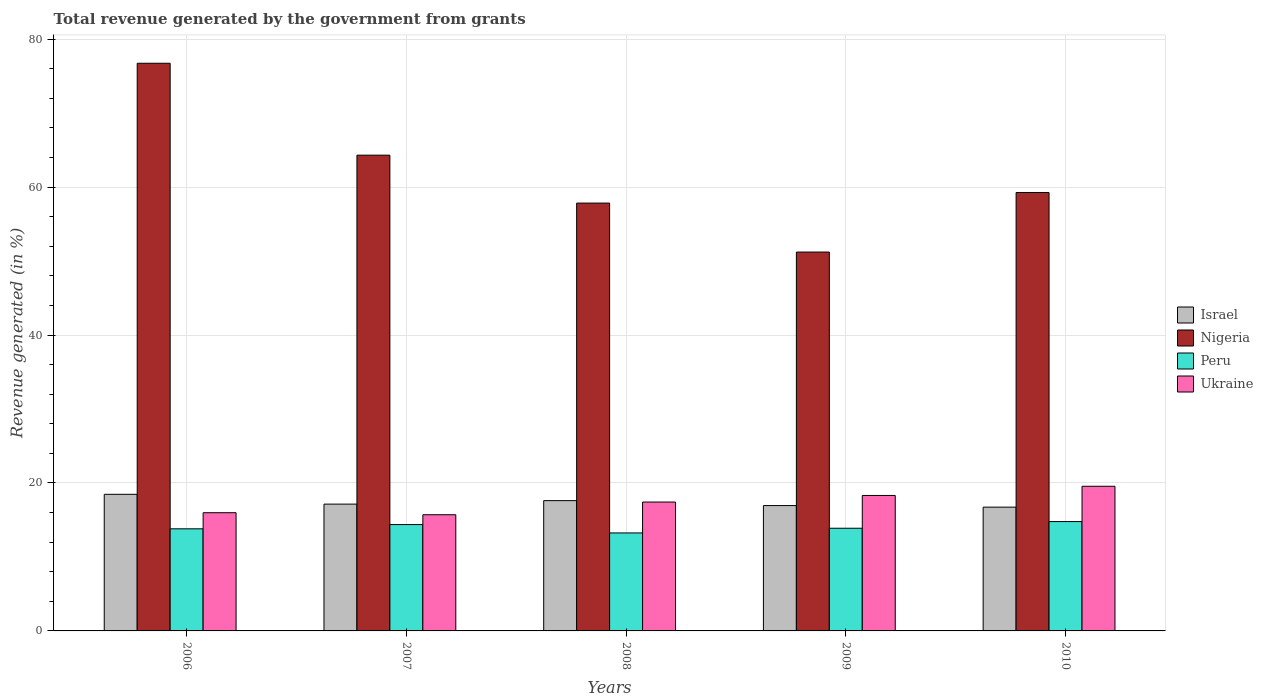How many different coloured bars are there?
Offer a very short reply. 4. What is the label of the 1st group of bars from the left?
Provide a succinct answer. 2006. In how many cases, is the number of bars for a given year not equal to the number of legend labels?
Your answer should be very brief. 0. What is the total revenue generated in Nigeria in 2009?
Offer a very short reply. 51.22. Across all years, what is the maximum total revenue generated in Ukraine?
Give a very brief answer. 19.55. Across all years, what is the minimum total revenue generated in Israel?
Provide a short and direct response. 16.73. What is the total total revenue generated in Ukraine in the graph?
Give a very brief answer. 86.97. What is the difference between the total revenue generated in Nigeria in 2006 and that in 2008?
Ensure brevity in your answer.  18.9. What is the difference between the total revenue generated in Ukraine in 2007 and the total revenue generated in Nigeria in 2008?
Make the answer very short. -42.13. What is the average total revenue generated in Peru per year?
Provide a succinct answer. 14.02. In the year 2008, what is the difference between the total revenue generated in Ukraine and total revenue generated in Peru?
Offer a very short reply. 4.18. What is the ratio of the total revenue generated in Ukraine in 2008 to that in 2009?
Offer a very short reply. 0.95. Is the total revenue generated in Peru in 2006 less than that in 2009?
Ensure brevity in your answer.  Yes. Is the difference between the total revenue generated in Ukraine in 2006 and 2007 greater than the difference between the total revenue generated in Peru in 2006 and 2007?
Your answer should be very brief. Yes. What is the difference between the highest and the second highest total revenue generated in Israel?
Make the answer very short. 0.85. What is the difference between the highest and the lowest total revenue generated in Peru?
Your answer should be compact. 1.54. In how many years, is the total revenue generated in Nigeria greater than the average total revenue generated in Nigeria taken over all years?
Provide a succinct answer. 2. Is the sum of the total revenue generated in Israel in 2006 and 2007 greater than the maximum total revenue generated in Ukraine across all years?
Provide a succinct answer. Yes. Are all the bars in the graph horizontal?
Provide a succinct answer. No. How many years are there in the graph?
Provide a short and direct response. 5. Are the values on the major ticks of Y-axis written in scientific E-notation?
Your answer should be compact. No. Does the graph contain any zero values?
Your answer should be compact. No. Does the graph contain grids?
Give a very brief answer. Yes. Where does the legend appear in the graph?
Your answer should be compact. Center right. How are the legend labels stacked?
Provide a succinct answer. Vertical. What is the title of the graph?
Your answer should be very brief. Total revenue generated by the government from grants. Does "Gambia, The" appear as one of the legend labels in the graph?
Your answer should be compact. No. What is the label or title of the Y-axis?
Provide a short and direct response. Revenue generated (in %). What is the Revenue generated (in %) in Israel in 2006?
Offer a terse response. 18.47. What is the Revenue generated (in %) of Nigeria in 2006?
Your answer should be compact. 76.74. What is the Revenue generated (in %) of Peru in 2006?
Your response must be concise. 13.8. What is the Revenue generated (in %) of Ukraine in 2006?
Provide a succinct answer. 15.98. What is the Revenue generated (in %) of Israel in 2007?
Keep it short and to the point. 17.14. What is the Revenue generated (in %) in Nigeria in 2007?
Provide a succinct answer. 64.31. What is the Revenue generated (in %) in Peru in 2007?
Provide a short and direct response. 14.38. What is the Revenue generated (in %) of Ukraine in 2007?
Offer a very short reply. 15.7. What is the Revenue generated (in %) of Israel in 2008?
Give a very brief answer. 17.61. What is the Revenue generated (in %) of Nigeria in 2008?
Ensure brevity in your answer.  57.84. What is the Revenue generated (in %) of Peru in 2008?
Ensure brevity in your answer.  13.24. What is the Revenue generated (in %) of Ukraine in 2008?
Provide a succinct answer. 17.42. What is the Revenue generated (in %) of Israel in 2009?
Give a very brief answer. 16.95. What is the Revenue generated (in %) of Nigeria in 2009?
Provide a short and direct response. 51.22. What is the Revenue generated (in %) in Peru in 2009?
Your answer should be very brief. 13.88. What is the Revenue generated (in %) in Ukraine in 2009?
Offer a terse response. 18.31. What is the Revenue generated (in %) of Israel in 2010?
Your response must be concise. 16.73. What is the Revenue generated (in %) in Nigeria in 2010?
Offer a very short reply. 59.27. What is the Revenue generated (in %) of Peru in 2010?
Make the answer very short. 14.78. What is the Revenue generated (in %) of Ukraine in 2010?
Your answer should be very brief. 19.55. Across all years, what is the maximum Revenue generated (in %) in Israel?
Your answer should be very brief. 18.47. Across all years, what is the maximum Revenue generated (in %) of Nigeria?
Your answer should be compact. 76.74. Across all years, what is the maximum Revenue generated (in %) in Peru?
Give a very brief answer. 14.78. Across all years, what is the maximum Revenue generated (in %) in Ukraine?
Offer a very short reply. 19.55. Across all years, what is the minimum Revenue generated (in %) in Israel?
Your answer should be compact. 16.73. Across all years, what is the minimum Revenue generated (in %) in Nigeria?
Your answer should be very brief. 51.22. Across all years, what is the minimum Revenue generated (in %) in Peru?
Make the answer very short. 13.24. Across all years, what is the minimum Revenue generated (in %) of Ukraine?
Your answer should be very brief. 15.7. What is the total Revenue generated (in %) of Israel in the graph?
Your response must be concise. 86.9. What is the total Revenue generated (in %) of Nigeria in the graph?
Your response must be concise. 309.37. What is the total Revenue generated (in %) in Peru in the graph?
Make the answer very short. 70.09. What is the total Revenue generated (in %) of Ukraine in the graph?
Give a very brief answer. 86.97. What is the difference between the Revenue generated (in %) of Israel in 2006 and that in 2007?
Keep it short and to the point. 1.32. What is the difference between the Revenue generated (in %) of Nigeria in 2006 and that in 2007?
Offer a terse response. 12.42. What is the difference between the Revenue generated (in %) of Peru in 2006 and that in 2007?
Offer a very short reply. -0.57. What is the difference between the Revenue generated (in %) of Ukraine in 2006 and that in 2007?
Keep it short and to the point. 0.28. What is the difference between the Revenue generated (in %) of Israel in 2006 and that in 2008?
Offer a very short reply. 0.85. What is the difference between the Revenue generated (in %) of Nigeria in 2006 and that in 2008?
Your answer should be compact. 18.9. What is the difference between the Revenue generated (in %) in Peru in 2006 and that in 2008?
Your answer should be very brief. 0.56. What is the difference between the Revenue generated (in %) in Ukraine in 2006 and that in 2008?
Offer a terse response. -1.44. What is the difference between the Revenue generated (in %) in Israel in 2006 and that in 2009?
Provide a succinct answer. 1.52. What is the difference between the Revenue generated (in %) in Nigeria in 2006 and that in 2009?
Your response must be concise. 25.52. What is the difference between the Revenue generated (in %) of Peru in 2006 and that in 2009?
Your answer should be very brief. -0.08. What is the difference between the Revenue generated (in %) in Ukraine in 2006 and that in 2009?
Keep it short and to the point. -2.33. What is the difference between the Revenue generated (in %) in Israel in 2006 and that in 2010?
Your answer should be very brief. 1.73. What is the difference between the Revenue generated (in %) in Nigeria in 2006 and that in 2010?
Offer a very short reply. 17.47. What is the difference between the Revenue generated (in %) of Peru in 2006 and that in 2010?
Your answer should be compact. -0.98. What is the difference between the Revenue generated (in %) in Ukraine in 2006 and that in 2010?
Make the answer very short. -3.57. What is the difference between the Revenue generated (in %) of Israel in 2007 and that in 2008?
Make the answer very short. -0.47. What is the difference between the Revenue generated (in %) of Nigeria in 2007 and that in 2008?
Offer a terse response. 6.48. What is the difference between the Revenue generated (in %) in Peru in 2007 and that in 2008?
Ensure brevity in your answer.  1.13. What is the difference between the Revenue generated (in %) in Ukraine in 2007 and that in 2008?
Provide a short and direct response. -1.72. What is the difference between the Revenue generated (in %) of Israel in 2007 and that in 2009?
Your answer should be very brief. 0.2. What is the difference between the Revenue generated (in %) in Nigeria in 2007 and that in 2009?
Provide a short and direct response. 13.1. What is the difference between the Revenue generated (in %) in Peru in 2007 and that in 2009?
Ensure brevity in your answer.  0.5. What is the difference between the Revenue generated (in %) of Ukraine in 2007 and that in 2009?
Keep it short and to the point. -2.61. What is the difference between the Revenue generated (in %) of Israel in 2007 and that in 2010?
Offer a very short reply. 0.41. What is the difference between the Revenue generated (in %) in Nigeria in 2007 and that in 2010?
Keep it short and to the point. 5.05. What is the difference between the Revenue generated (in %) of Peru in 2007 and that in 2010?
Provide a succinct answer. -0.41. What is the difference between the Revenue generated (in %) of Ukraine in 2007 and that in 2010?
Provide a succinct answer. -3.85. What is the difference between the Revenue generated (in %) of Israel in 2008 and that in 2009?
Provide a short and direct response. 0.67. What is the difference between the Revenue generated (in %) of Nigeria in 2008 and that in 2009?
Offer a terse response. 6.62. What is the difference between the Revenue generated (in %) of Peru in 2008 and that in 2009?
Your response must be concise. -0.64. What is the difference between the Revenue generated (in %) of Ukraine in 2008 and that in 2009?
Your answer should be compact. -0.89. What is the difference between the Revenue generated (in %) in Israel in 2008 and that in 2010?
Your answer should be very brief. 0.88. What is the difference between the Revenue generated (in %) in Nigeria in 2008 and that in 2010?
Keep it short and to the point. -1.43. What is the difference between the Revenue generated (in %) in Peru in 2008 and that in 2010?
Your answer should be compact. -1.54. What is the difference between the Revenue generated (in %) of Ukraine in 2008 and that in 2010?
Give a very brief answer. -2.13. What is the difference between the Revenue generated (in %) of Israel in 2009 and that in 2010?
Your answer should be compact. 0.21. What is the difference between the Revenue generated (in %) in Nigeria in 2009 and that in 2010?
Ensure brevity in your answer.  -8.05. What is the difference between the Revenue generated (in %) in Peru in 2009 and that in 2010?
Give a very brief answer. -0.9. What is the difference between the Revenue generated (in %) of Ukraine in 2009 and that in 2010?
Ensure brevity in your answer.  -1.24. What is the difference between the Revenue generated (in %) of Israel in 2006 and the Revenue generated (in %) of Nigeria in 2007?
Your answer should be compact. -45.85. What is the difference between the Revenue generated (in %) of Israel in 2006 and the Revenue generated (in %) of Peru in 2007?
Provide a succinct answer. 4.09. What is the difference between the Revenue generated (in %) of Israel in 2006 and the Revenue generated (in %) of Ukraine in 2007?
Give a very brief answer. 2.76. What is the difference between the Revenue generated (in %) of Nigeria in 2006 and the Revenue generated (in %) of Peru in 2007?
Offer a terse response. 62.36. What is the difference between the Revenue generated (in %) of Nigeria in 2006 and the Revenue generated (in %) of Ukraine in 2007?
Your response must be concise. 61.03. What is the difference between the Revenue generated (in %) in Peru in 2006 and the Revenue generated (in %) in Ukraine in 2007?
Make the answer very short. -1.9. What is the difference between the Revenue generated (in %) of Israel in 2006 and the Revenue generated (in %) of Nigeria in 2008?
Ensure brevity in your answer.  -39.37. What is the difference between the Revenue generated (in %) of Israel in 2006 and the Revenue generated (in %) of Peru in 2008?
Give a very brief answer. 5.22. What is the difference between the Revenue generated (in %) in Israel in 2006 and the Revenue generated (in %) in Ukraine in 2008?
Make the answer very short. 1.04. What is the difference between the Revenue generated (in %) of Nigeria in 2006 and the Revenue generated (in %) of Peru in 2008?
Your answer should be compact. 63.49. What is the difference between the Revenue generated (in %) of Nigeria in 2006 and the Revenue generated (in %) of Ukraine in 2008?
Your response must be concise. 59.32. What is the difference between the Revenue generated (in %) of Peru in 2006 and the Revenue generated (in %) of Ukraine in 2008?
Ensure brevity in your answer.  -3.62. What is the difference between the Revenue generated (in %) of Israel in 2006 and the Revenue generated (in %) of Nigeria in 2009?
Offer a very short reply. -32.75. What is the difference between the Revenue generated (in %) in Israel in 2006 and the Revenue generated (in %) in Peru in 2009?
Offer a terse response. 4.59. What is the difference between the Revenue generated (in %) of Israel in 2006 and the Revenue generated (in %) of Ukraine in 2009?
Keep it short and to the point. 0.15. What is the difference between the Revenue generated (in %) in Nigeria in 2006 and the Revenue generated (in %) in Peru in 2009?
Provide a succinct answer. 62.86. What is the difference between the Revenue generated (in %) in Nigeria in 2006 and the Revenue generated (in %) in Ukraine in 2009?
Your response must be concise. 58.43. What is the difference between the Revenue generated (in %) of Peru in 2006 and the Revenue generated (in %) of Ukraine in 2009?
Ensure brevity in your answer.  -4.51. What is the difference between the Revenue generated (in %) in Israel in 2006 and the Revenue generated (in %) in Nigeria in 2010?
Offer a terse response. -40.8. What is the difference between the Revenue generated (in %) in Israel in 2006 and the Revenue generated (in %) in Peru in 2010?
Give a very brief answer. 3.68. What is the difference between the Revenue generated (in %) of Israel in 2006 and the Revenue generated (in %) of Ukraine in 2010?
Ensure brevity in your answer.  -1.09. What is the difference between the Revenue generated (in %) of Nigeria in 2006 and the Revenue generated (in %) of Peru in 2010?
Make the answer very short. 61.96. What is the difference between the Revenue generated (in %) in Nigeria in 2006 and the Revenue generated (in %) in Ukraine in 2010?
Your response must be concise. 57.18. What is the difference between the Revenue generated (in %) of Peru in 2006 and the Revenue generated (in %) of Ukraine in 2010?
Your answer should be very brief. -5.75. What is the difference between the Revenue generated (in %) of Israel in 2007 and the Revenue generated (in %) of Nigeria in 2008?
Give a very brief answer. -40.69. What is the difference between the Revenue generated (in %) in Israel in 2007 and the Revenue generated (in %) in Peru in 2008?
Provide a short and direct response. 3.9. What is the difference between the Revenue generated (in %) in Israel in 2007 and the Revenue generated (in %) in Ukraine in 2008?
Provide a short and direct response. -0.28. What is the difference between the Revenue generated (in %) in Nigeria in 2007 and the Revenue generated (in %) in Peru in 2008?
Provide a succinct answer. 51.07. What is the difference between the Revenue generated (in %) in Nigeria in 2007 and the Revenue generated (in %) in Ukraine in 2008?
Your answer should be very brief. 46.89. What is the difference between the Revenue generated (in %) in Peru in 2007 and the Revenue generated (in %) in Ukraine in 2008?
Offer a terse response. -3.05. What is the difference between the Revenue generated (in %) in Israel in 2007 and the Revenue generated (in %) in Nigeria in 2009?
Offer a very short reply. -34.07. What is the difference between the Revenue generated (in %) of Israel in 2007 and the Revenue generated (in %) of Peru in 2009?
Ensure brevity in your answer.  3.26. What is the difference between the Revenue generated (in %) of Israel in 2007 and the Revenue generated (in %) of Ukraine in 2009?
Keep it short and to the point. -1.17. What is the difference between the Revenue generated (in %) in Nigeria in 2007 and the Revenue generated (in %) in Peru in 2009?
Offer a terse response. 50.43. What is the difference between the Revenue generated (in %) in Nigeria in 2007 and the Revenue generated (in %) in Ukraine in 2009?
Offer a very short reply. 46. What is the difference between the Revenue generated (in %) of Peru in 2007 and the Revenue generated (in %) of Ukraine in 2009?
Your answer should be very brief. -3.93. What is the difference between the Revenue generated (in %) of Israel in 2007 and the Revenue generated (in %) of Nigeria in 2010?
Offer a very short reply. -42.13. What is the difference between the Revenue generated (in %) in Israel in 2007 and the Revenue generated (in %) in Peru in 2010?
Provide a succinct answer. 2.36. What is the difference between the Revenue generated (in %) in Israel in 2007 and the Revenue generated (in %) in Ukraine in 2010?
Offer a very short reply. -2.41. What is the difference between the Revenue generated (in %) in Nigeria in 2007 and the Revenue generated (in %) in Peru in 2010?
Keep it short and to the point. 49.53. What is the difference between the Revenue generated (in %) of Nigeria in 2007 and the Revenue generated (in %) of Ukraine in 2010?
Give a very brief answer. 44.76. What is the difference between the Revenue generated (in %) of Peru in 2007 and the Revenue generated (in %) of Ukraine in 2010?
Provide a short and direct response. -5.18. What is the difference between the Revenue generated (in %) in Israel in 2008 and the Revenue generated (in %) in Nigeria in 2009?
Offer a very short reply. -33.6. What is the difference between the Revenue generated (in %) of Israel in 2008 and the Revenue generated (in %) of Peru in 2009?
Keep it short and to the point. 3.73. What is the difference between the Revenue generated (in %) of Israel in 2008 and the Revenue generated (in %) of Ukraine in 2009?
Offer a terse response. -0.7. What is the difference between the Revenue generated (in %) in Nigeria in 2008 and the Revenue generated (in %) in Peru in 2009?
Your answer should be very brief. 43.96. What is the difference between the Revenue generated (in %) in Nigeria in 2008 and the Revenue generated (in %) in Ukraine in 2009?
Offer a very short reply. 39.52. What is the difference between the Revenue generated (in %) in Peru in 2008 and the Revenue generated (in %) in Ukraine in 2009?
Your answer should be very brief. -5.07. What is the difference between the Revenue generated (in %) of Israel in 2008 and the Revenue generated (in %) of Nigeria in 2010?
Your answer should be very brief. -41.65. What is the difference between the Revenue generated (in %) in Israel in 2008 and the Revenue generated (in %) in Peru in 2010?
Your answer should be compact. 2.83. What is the difference between the Revenue generated (in %) of Israel in 2008 and the Revenue generated (in %) of Ukraine in 2010?
Offer a very short reply. -1.94. What is the difference between the Revenue generated (in %) in Nigeria in 2008 and the Revenue generated (in %) in Peru in 2010?
Give a very brief answer. 43.05. What is the difference between the Revenue generated (in %) of Nigeria in 2008 and the Revenue generated (in %) of Ukraine in 2010?
Provide a short and direct response. 38.28. What is the difference between the Revenue generated (in %) in Peru in 2008 and the Revenue generated (in %) in Ukraine in 2010?
Make the answer very short. -6.31. What is the difference between the Revenue generated (in %) in Israel in 2009 and the Revenue generated (in %) in Nigeria in 2010?
Keep it short and to the point. -42.32. What is the difference between the Revenue generated (in %) of Israel in 2009 and the Revenue generated (in %) of Peru in 2010?
Give a very brief answer. 2.16. What is the difference between the Revenue generated (in %) of Israel in 2009 and the Revenue generated (in %) of Ukraine in 2010?
Offer a very short reply. -2.61. What is the difference between the Revenue generated (in %) in Nigeria in 2009 and the Revenue generated (in %) in Peru in 2010?
Keep it short and to the point. 36.43. What is the difference between the Revenue generated (in %) of Nigeria in 2009 and the Revenue generated (in %) of Ukraine in 2010?
Your response must be concise. 31.66. What is the difference between the Revenue generated (in %) in Peru in 2009 and the Revenue generated (in %) in Ukraine in 2010?
Ensure brevity in your answer.  -5.67. What is the average Revenue generated (in %) in Israel per year?
Provide a short and direct response. 17.38. What is the average Revenue generated (in %) in Nigeria per year?
Provide a short and direct response. 61.87. What is the average Revenue generated (in %) of Peru per year?
Ensure brevity in your answer.  14.02. What is the average Revenue generated (in %) of Ukraine per year?
Give a very brief answer. 17.39. In the year 2006, what is the difference between the Revenue generated (in %) in Israel and Revenue generated (in %) in Nigeria?
Ensure brevity in your answer.  -58.27. In the year 2006, what is the difference between the Revenue generated (in %) in Israel and Revenue generated (in %) in Peru?
Your answer should be compact. 4.66. In the year 2006, what is the difference between the Revenue generated (in %) of Israel and Revenue generated (in %) of Ukraine?
Give a very brief answer. 2.48. In the year 2006, what is the difference between the Revenue generated (in %) in Nigeria and Revenue generated (in %) in Peru?
Give a very brief answer. 62.94. In the year 2006, what is the difference between the Revenue generated (in %) in Nigeria and Revenue generated (in %) in Ukraine?
Make the answer very short. 60.76. In the year 2006, what is the difference between the Revenue generated (in %) in Peru and Revenue generated (in %) in Ukraine?
Give a very brief answer. -2.18. In the year 2007, what is the difference between the Revenue generated (in %) of Israel and Revenue generated (in %) of Nigeria?
Ensure brevity in your answer.  -47.17. In the year 2007, what is the difference between the Revenue generated (in %) in Israel and Revenue generated (in %) in Peru?
Your answer should be compact. 2.76. In the year 2007, what is the difference between the Revenue generated (in %) in Israel and Revenue generated (in %) in Ukraine?
Provide a short and direct response. 1.44. In the year 2007, what is the difference between the Revenue generated (in %) of Nigeria and Revenue generated (in %) of Peru?
Offer a very short reply. 49.94. In the year 2007, what is the difference between the Revenue generated (in %) of Nigeria and Revenue generated (in %) of Ukraine?
Offer a terse response. 48.61. In the year 2007, what is the difference between the Revenue generated (in %) of Peru and Revenue generated (in %) of Ukraine?
Offer a terse response. -1.33. In the year 2008, what is the difference between the Revenue generated (in %) in Israel and Revenue generated (in %) in Nigeria?
Keep it short and to the point. -40.22. In the year 2008, what is the difference between the Revenue generated (in %) in Israel and Revenue generated (in %) in Peru?
Offer a terse response. 4.37. In the year 2008, what is the difference between the Revenue generated (in %) of Israel and Revenue generated (in %) of Ukraine?
Ensure brevity in your answer.  0.19. In the year 2008, what is the difference between the Revenue generated (in %) in Nigeria and Revenue generated (in %) in Peru?
Ensure brevity in your answer.  44.59. In the year 2008, what is the difference between the Revenue generated (in %) in Nigeria and Revenue generated (in %) in Ukraine?
Offer a terse response. 40.41. In the year 2008, what is the difference between the Revenue generated (in %) in Peru and Revenue generated (in %) in Ukraine?
Your response must be concise. -4.18. In the year 2009, what is the difference between the Revenue generated (in %) of Israel and Revenue generated (in %) of Nigeria?
Make the answer very short. -34.27. In the year 2009, what is the difference between the Revenue generated (in %) in Israel and Revenue generated (in %) in Peru?
Provide a short and direct response. 3.06. In the year 2009, what is the difference between the Revenue generated (in %) of Israel and Revenue generated (in %) of Ukraine?
Provide a short and direct response. -1.37. In the year 2009, what is the difference between the Revenue generated (in %) in Nigeria and Revenue generated (in %) in Peru?
Keep it short and to the point. 37.34. In the year 2009, what is the difference between the Revenue generated (in %) of Nigeria and Revenue generated (in %) of Ukraine?
Your answer should be very brief. 32.91. In the year 2009, what is the difference between the Revenue generated (in %) in Peru and Revenue generated (in %) in Ukraine?
Offer a very short reply. -4.43. In the year 2010, what is the difference between the Revenue generated (in %) in Israel and Revenue generated (in %) in Nigeria?
Your response must be concise. -42.54. In the year 2010, what is the difference between the Revenue generated (in %) of Israel and Revenue generated (in %) of Peru?
Ensure brevity in your answer.  1.95. In the year 2010, what is the difference between the Revenue generated (in %) in Israel and Revenue generated (in %) in Ukraine?
Your answer should be very brief. -2.82. In the year 2010, what is the difference between the Revenue generated (in %) in Nigeria and Revenue generated (in %) in Peru?
Provide a succinct answer. 44.49. In the year 2010, what is the difference between the Revenue generated (in %) in Nigeria and Revenue generated (in %) in Ukraine?
Ensure brevity in your answer.  39.71. In the year 2010, what is the difference between the Revenue generated (in %) in Peru and Revenue generated (in %) in Ukraine?
Make the answer very short. -4.77. What is the ratio of the Revenue generated (in %) of Israel in 2006 to that in 2007?
Offer a terse response. 1.08. What is the ratio of the Revenue generated (in %) in Nigeria in 2006 to that in 2007?
Offer a very short reply. 1.19. What is the ratio of the Revenue generated (in %) of Peru in 2006 to that in 2007?
Provide a short and direct response. 0.96. What is the ratio of the Revenue generated (in %) in Ukraine in 2006 to that in 2007?
Offer a very short reply. 1.02. What is the ratio of the Revenue generated (in %) of Israel in 2006 to that in 2008?
Your response must be concise. 1.05. What is the ratio of the Revenue generated (in %) of Nigeria in 2006 to that in 2008?
Offer a very short reply. 1.33. What is the ratio of the Revenue generated (in %) in Peru in 2006 to that in 2008?
Give a very brief answer. 1.04. What is the ratio of the Revenue generated (in %) of Ukraine in 2006 to that in 2008?
Offer a very short reply. 0.92. What is the ratio of the Revenue generated (in %) of Israel in 2006 to that in 2009?
Your answer should be very brief. 1.09. What is the ratio of the Revenue generated (in %) of Nigeria in 2006 to that in 2009?
Your response must be concise. 1.5. What is the ratio of the Revenue generated (in %) in Peru in 2006 to that in 2009?
Offer a terse response. 0.99. What is the ratio of the Revenue generated (in %) in Ukraine in 2006 to that in 2009?
Make the answer very short. 0.87. What is the ratio of the Revenue generated (in %) in Israel in 2006 to that in 2010?
Offer a terse response. 1.1. What is the ratio of the Revenue generated (in %) in Nigeria in 2006 to that in 2010?
Keep it short and to the point. 1.29. What is the ratio of the Revenue generated (in %) in Peru in 2006 to that in 2010?
Provide a succinct answer. 0.93. What is the ratio of the Revenue generated (in %) in Ukraine in 2006 to that in 2010?
Make the answer very short. 0.82. What is the ratio of the Revenue generated (in %) of Israel in 2007 to that in 2008?
Keep it short and to the point. 0.97. What is the ratio of the Revenue generated (in %) of Nigeria in 2007 to that in 2008?
Your answer should be very brief. 1.11. What is the ratio of the Revenue generated (in %) in Peru in 2007 to that in 2008?
Your response must be concise. 1.09. What is the ratio of the Revenue generated (in %) in Ukraine in 2007 to that in 2008?
Ensure brevity in your answer.  0.9. What is the ratio of the Revenue generated (in %) of Israel in 2007 to that in 2009?
Your response must be concise. 1.01. What is the ratio of the Revenue generated (in %) in Nigeria in 2007 to that in 2009?
Your answer should be very brief. 1.26. What is the ratio of the Revenue generated (in %) of Peru in 2007 to that in 2009?
Your answer should be compact. 1.04. What is the ratio of the Revenue generated (in %) in Ukraine in 2007 to that in 2009?
Ensure brevity in your answer.  0.86. What is the ratio of the Revenue generated (in %) in Israel in 2007 to that in 2010?
Provide a short and direct response. 1.02. What is the ratio of the Revenue generated (in %) in Nigeria in 2007 to that in 2010?
Offer a terse response. 1.09. What is the ratio of the Revenue generated (in %) of Peru in 2007 to that in 2010?
Your answer should be compact. 0.97. What is the ratio of the Revenue generated (in %) in Ukraine in 2007 to that in 2010?
Give a very brief answer. 0.8. What is the ratio of the Revenue generated (in %) in Israel in 2008 to that in 2009?
Offer a very short reply. 1.04. What is the ratio of the Revenue generated (in %) in Nigeria in 2008 to that in 2009?
Ensure brevity in your answer.  1.13. What is the ratio of the Revenue generated (in %) in Peru in 2008 to that in 2009?
Keep it short and to the point. 0.95. What is the ratio of the Revenue generated (in %) in Ukraine in 2008 to that in 2009?
Your answer should be very brief. 0.95. What is the ratio of the Revenue generated (in %) in Israel in 2008 to that in 2010?
Give a very brief answer. 1.05. What is the ratio of the Revenue generated (in %) in Nigeria in 2008 to that in 2010?
Provide a succinct answer. 0.98. What is the ratio of the Revenue generated (in %) in Peru in 2008 to that in 2010?
Offer a very short reply. 0.9. What is the ratio of the Revenue generated (in %) of Ukraine in 2008 to that in 2010?
Ensure brevity in your answer.  0.89. What is the ratio of the Revenue generated (in %) of Israel in 2009 to that in 2010?
Offer a terse response. 1.01. What is the ratio of the Revenue generated (in %) in Nigeria in 2009 to that in 2010?
Your answer should be compact. 0.86. What is the ratio of the Revenue generated (in %) of Peru in 2009 to that in 2010?
Give a very brief answer. 0.94. What is the ratio of the Revenue generated (in %) of Ukraine in 2009 to that in 2010?
Provide a succinct answer. 0.94. What is the difference between the highest and the second highest Revenue generated (in %) in Israel?
Ensure brevity in your answer.  0.85. What is the difference between the highest and the second highest Revenue generated (in %) of Nigeria?
Keep it short and to the point. 12.42. What is the difference between the highest and the second highest Revenue generated (in %) in Peru?
Keep it short and to the point. 0.41. What is the difference between the highest and the second highest Revenue generated (in %) in Ukraine?
Give a very brief answer. 1.24. What is the difference between the highest and the lowest Revenue generated (in %) of Israel?
Provide a succinct answer. 1.73. What is the difference between the highest and the lowest Revenue generated (in %) in Nigeria?
Offer a terse response. 25.52. What is the difference between the highest and the lowest Revenue generated (in %) of Peru?
Give a very brief answer. 1.54. What is the difference between the highest and the lowest Revenue generated (in %) in Ukraine?
Provide a succinct answer. 3.85. 